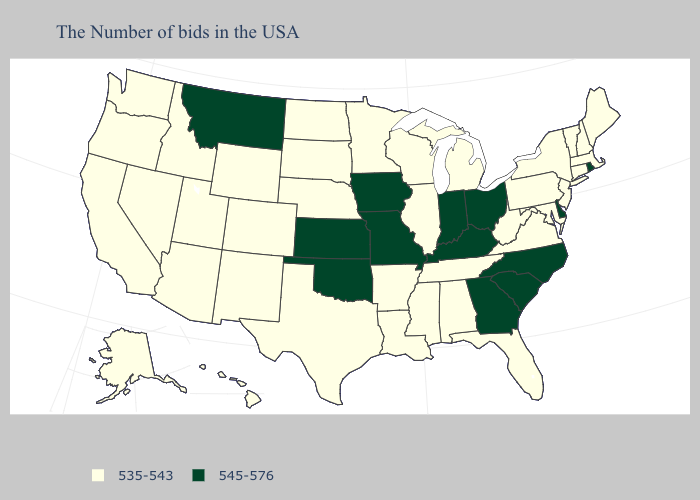Among the states that border Idaho , does Montana have the highest value?
Quick response, please. Yes. Name the states that have a value in the range 545-576?
Quick response, please. Rhode Island, Delaware, North Carolina, South Carolina, Ohio, Georgia, Kentucky, Indiana, Missouri, Iowa, Kansas, Oklahoma, Montana. Among the states that border Indiana , does Kentucky have the lowest value?
Give a very brief answer. No. Does Montana have the lowest value in the USA?
Answer briefly. No. What is the highest value in the Northeast ?
Concise answer only. 545-576. Does Illinois have the highest value in the MidWest?
Concise answer only. No. What is the highest value in states that border West Virginia?
Concise answer only. 545-576. What is the lowest value in the USA?
Quick response, please. 535-543. What is the value of Arizona?
Give a very brief answer. 535-543. What is the highest value in the USA?
Short answer required. 545-576. Does Maryland have the lowest value in the USA?
Write a very short answer. Yes. Name the states that have a value in the range 545-576?
Concise answer only. Rhode Island, Delaware, North Carolina, South Carolina, Ohio, Georgia, Kentucky, Indiana, Missouri, Iowa, Kansas, Oklahoma, Montana. Does Indiana have the highest value in the USA?
Write a very short answer. Yes. Name the states that have a value in the range 535-543?
Keep it brief. Maine, Massachusetts, New Hampshire, Vermont, Connecticut, New York, New Jersey, Maryland, Pennsylvania, Virginia, West Virginia, Florida, Michigan, Alabama, Tennessee, Wisconsin, Illinois, Mississippi, Louisiana, Arkansas, Minnesota, Nebraska, Texas, South Dakota, North Dakota, Wyoming, Colorado, New Mexico, Utah, Arizona, Idaho, Nevada, California, Washington, Oregon, Alaska, Hawaii. What is the value of North Carolina?
Short answer required. 545-576. 